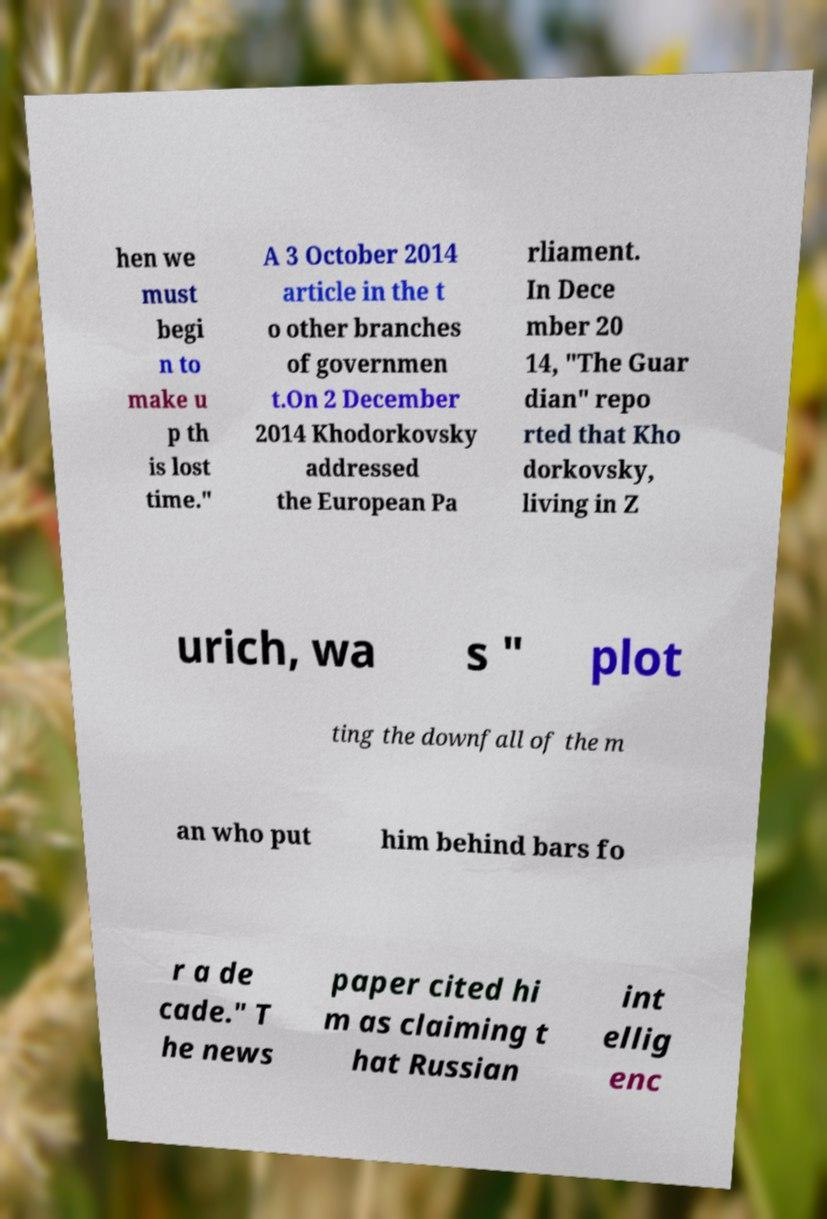Can you read and provide the text displayed in the image?This photo seems to have some interesting text. Can you extract and type it out for me? hen we must begi n to make u p th is lost time." A 3 October 2014 article in the t o other branches of governmen t.On 2 December 2014 Khodorkovsky addressed the European Pa rliament. In Dece mber 20 14, "The Guar dian" repo rted that Kho dorkovsky, living in Z urich, wa s " plot ting the downfall of the m an who put him behind bars fo r a de cade." T he news paper cited hi m as claiming t hat Russian int ellig enc 